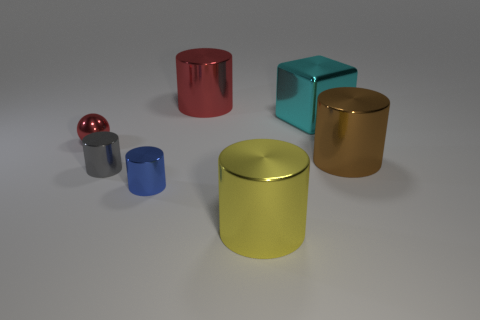There is a large metallic cylinder behind the brown shiny thing; is its color the same as the small metal ball?
Your answer should be compact. Yes. Is the color of the metal sphere the same as the big cylinder to the left of the big yellow object?
Make the answer very short. Yes. Are there any cylinders of the same color as the shiny sphere?
Give a very brief answer. Yes. There is a thing that is the same color as the tiny ball; what material is it?
Offer a terse response. Metal. There is a red shiny object that is the same size as the gray cylinder; what is its shape?
Your response must be concise. Sphere. What number of other objects are the same shape as the gray metallic object?
Your answer should be very brief. 4. There is a blue metal cylinder; is its size the same as the metallic cylinder that is to the right of the yellow metal cylinder?
Give a very brief answer. No. How many things are things right of the large red shiny thing or balls?
Provide a succinct answer. 4. What is the shape of the thing on the right side of the large shiny block?
Provide a short and direct response. Cylinder. Are there the same number of big things behind the blue object and large yellow metal cylinders that are behind the gray cylinder?
Your answer should be very brief. No. 